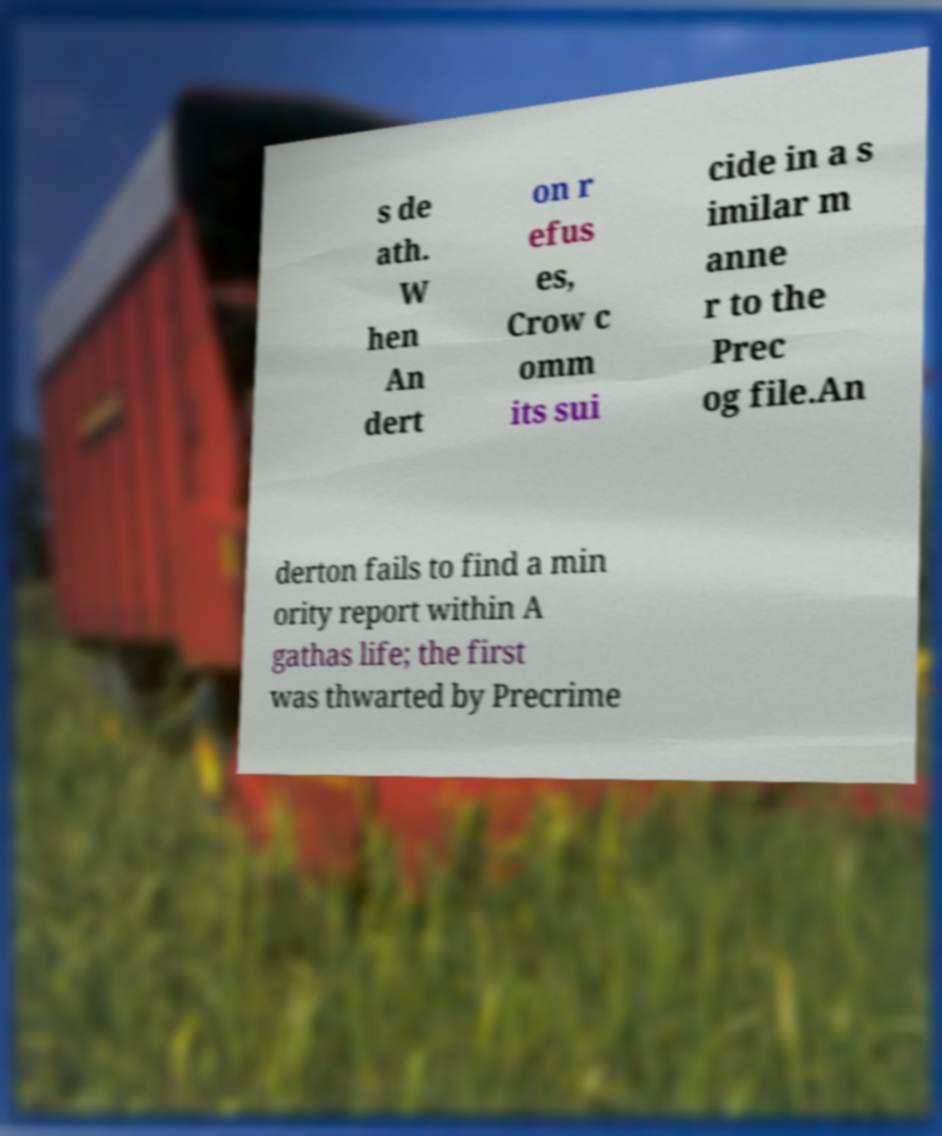Could you assist in decoding the text presented in this image and type it out clearly? s de ath. W hen An dert on r efus es, Crow c omm its sui cide in a s imilar m anne r to the Prec og file.An derton fails to find a min ority report within A gathas life; the first was thwarted by Precrime 